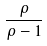<formula> <loc_0><loc_0><loc_500><loc_500>\frac { \rho } { \rho - 1 }</formula> 